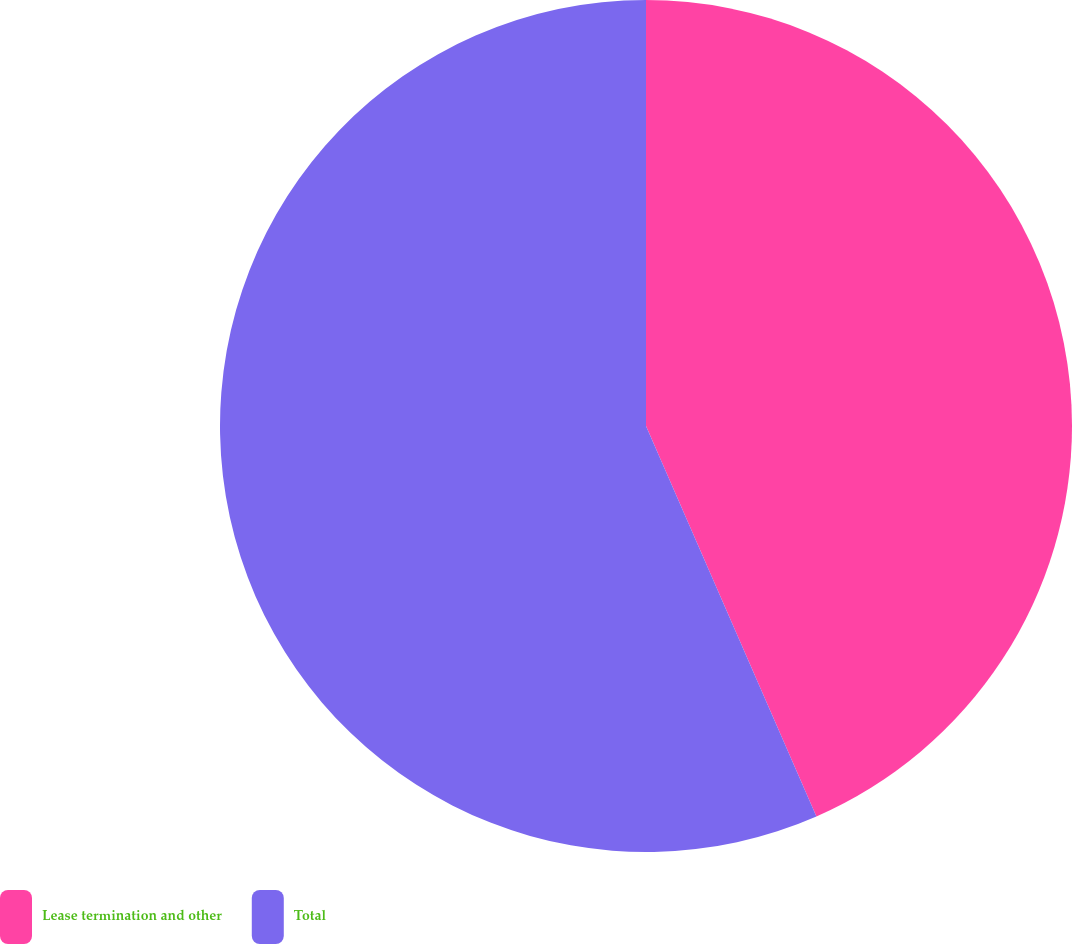<chart> <loc_0><loc_0><loc_500><loc_500><pie_chart><fcel>Lease termination and other<fcel>Total<nl><fcel>43.45%<fcel>56.55%<nl></chart> 